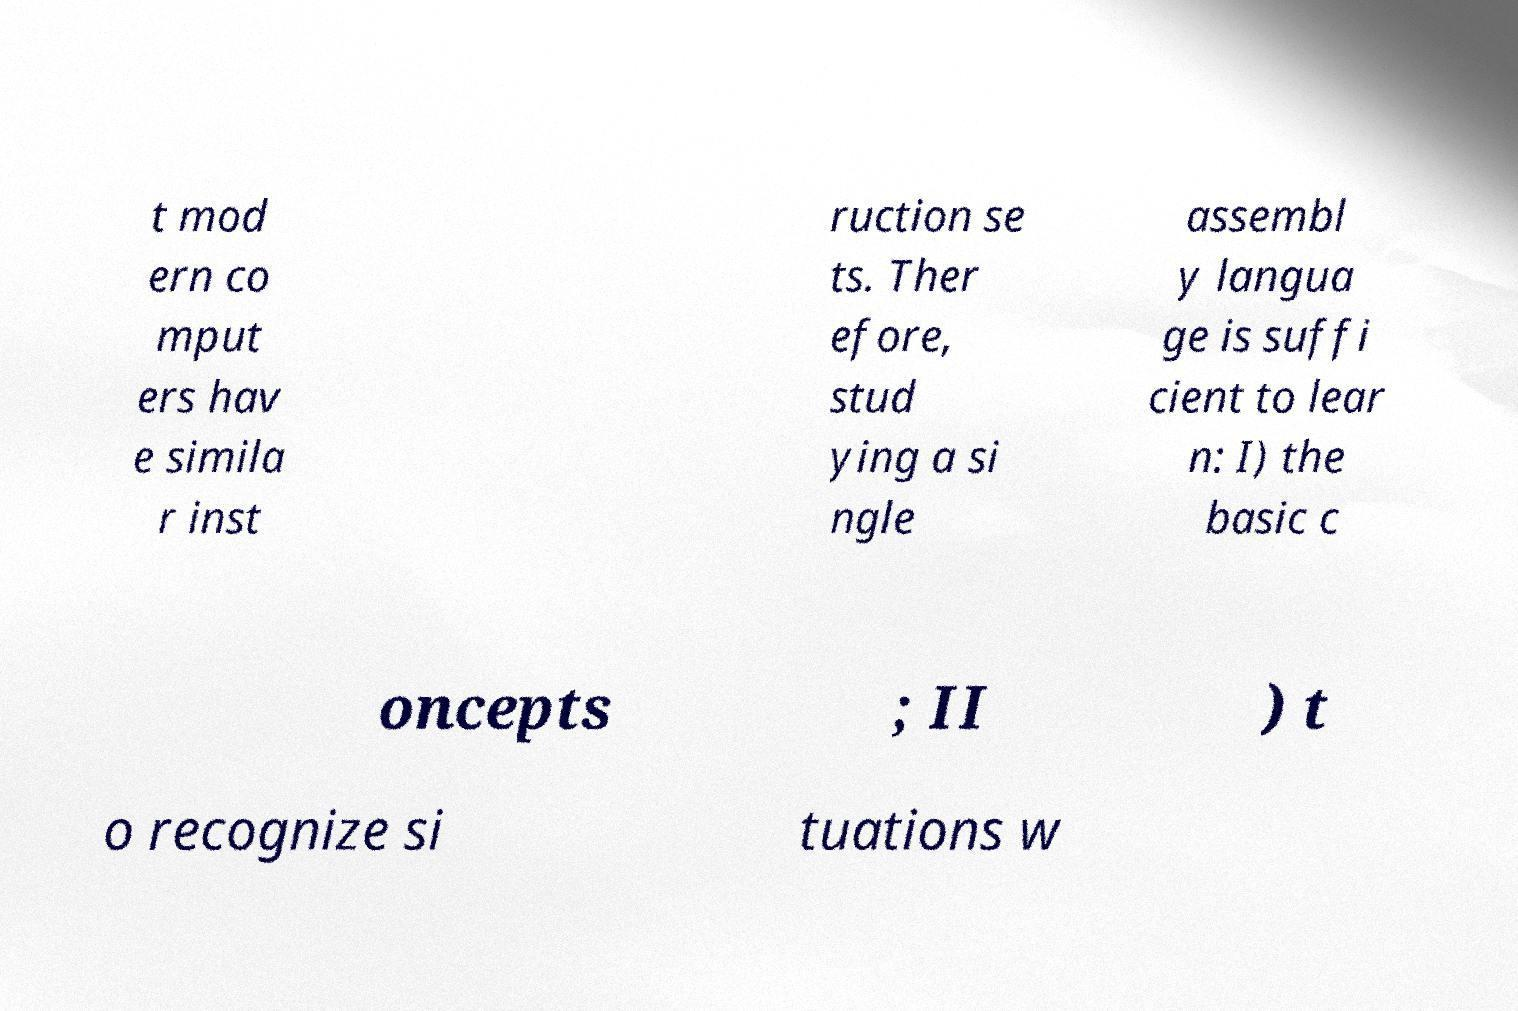Please read and relay the text visible in this image. What does it say? t mod ern co mput ers hav e simila r inst ruction se ts. Ther efore, stud ying a si ngle assembl y langua ge is suffi cient to lear n: I) the basic c oncepts ; II ) t o recognize si tuations w 